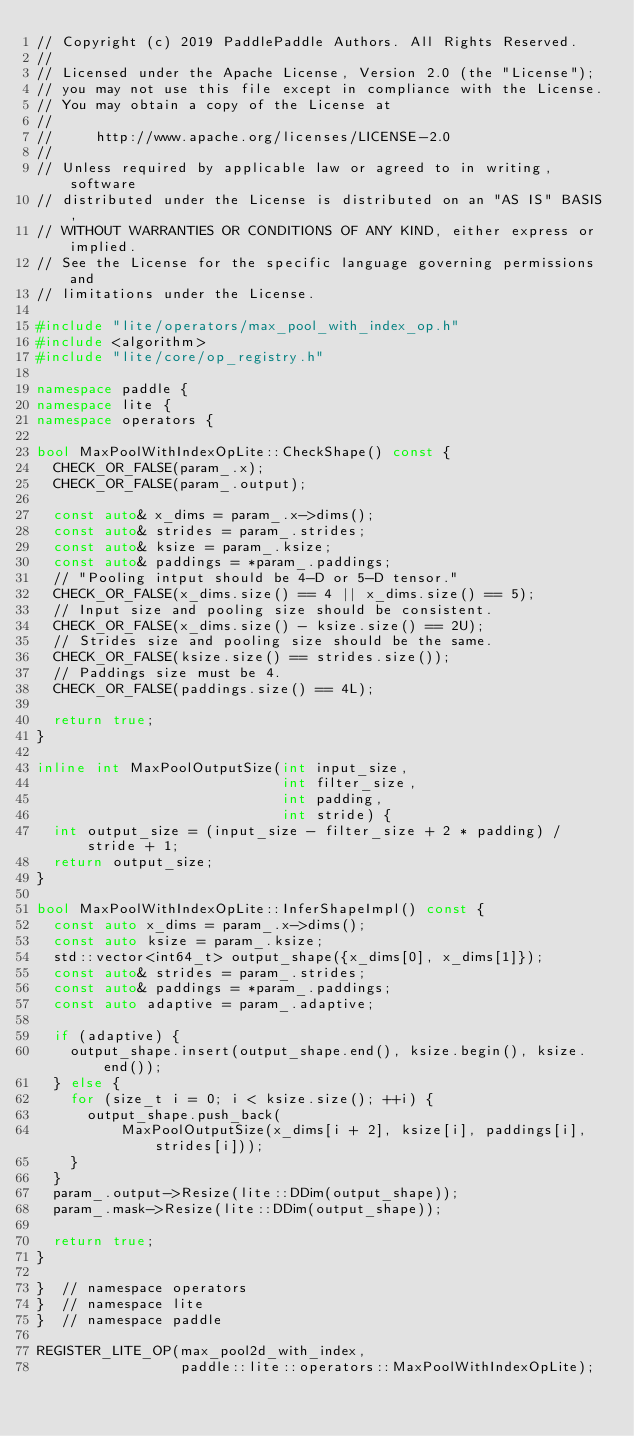<code> <loc_0><loc_0><loc_500><loc_500><_C++_>// Copyright (c) 2019 PaddlePaddle Authors. All Rights Reserved.
//
// Licensed under the Apache License, Version 2.0 (the "License");
// you may not use this file except in compliance with the License.
// You may obtain a copy of the License at
//
//     http://www.apache.org/licenses/LICENSE-2.0
//
// Unless required by applicable law or agreed to in writing, software
// distributed under the License is distributed on an "AS IS" BASIS,
// WITHOUT WARRANTIES OR CONDITIONS OF ANY KIND, either express or implied.
// See the License for the specific language governing permissions and
// limitations under the License.

#include "lite/operators/max_pool_with_index_op.h"
#include <algorithm>
#include "lite/core/op_registry.h"

namespace paddle {
namespace lite {
namespace operators {

bool MaxPoolWithIndexOpLite::CheckShape() const {
  CHECK_OR_FALSE(param_.x);
  CHECK_OR_FALSE(param_.output);

  const auto& x_dims = param_.x->dims();
  const auto& strides = param_.strides;
  const auto& ksize = param_.ksize;
  const auto& paddings = *param_.paddings;
  // "Pooling intput should be 4-D or 5-D tensor."
  CHECK_OR_FALSE(x_dims.size() == 4 || x_dims.size() == 5);
  // Input size and pooling size should be consistent.
  CHECK_OR_FALSE(x_dims.size() - ksize.size() == 2U);
  // Strides size and pooling size should be the same.
  CHECK_OR_FALSE(ksize.size() == strides.size());
  // Paddings size must be 4.
  CHECK_OR_FALSE(paddings.size() == 4L);

  return true;
}

inline int MaxPoolOutputSize(int input_size,
                             int filter_size,
                             int padding,
                             int stride) {
  int output_size = (input_size - filter_size + 2 * padding) / stride + 1;
  return output_size;
}

bool MaxPoolWithIndexOpLite::InferShapeImpl() const {
  const auto x_dims = param_.x->dims();
  const auto ksize = param_.ksize;
  std::vector<int64_t> output_shape({x_dims[0], x_dims[1]});
  const auto& strides = param_.strides;
  const auto& paddings = *param_.paddings;
  const auto adaptive = param_.adaptive;

  if (adaptive) {
    output_shape.insert(output_shape.end(), ksize.begin(), ksize.end());
  } else {
    for (size_t i = 0; i < ksize.size(); ++i) {
      output_shape.push_back(
          MaxPoolOutputSize(x_dims[i + 2], ksize[i], paddings[i], strides[i]));
    }
  }
  param_.output->Resize(lite::DDim(output_shape));
  param_.mask->Resize(lite::DDim(output_shape));

  return true;
}

}  // namespace operators
}  // namespace lite
}  // namespace paddle

REGISTER_LITE_OP(max_pool2d_with_index,
                 paddle::lite::operators::MaxPoolWithIndexOpLite);
</code> 